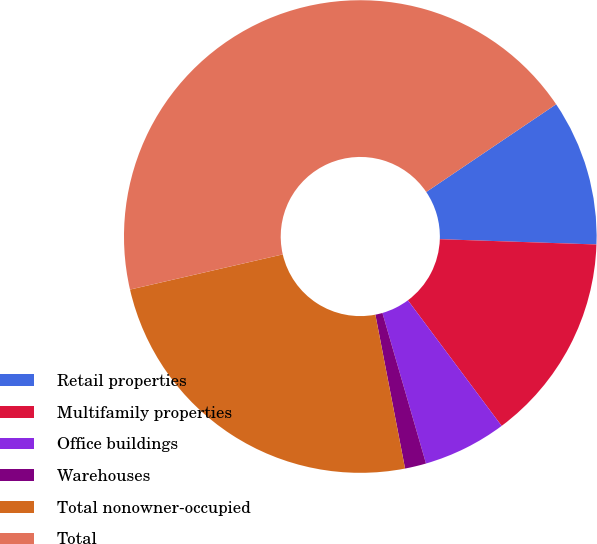Convert chart. <chart><loc_0><loc_0><loc_500><loc_500><pie_chart><fcel>Retail properties<fcel>Multifamily properties<fcel>Office buildings<fcel>Warehouses<fcel>Total nonowner-occupied<fcel>Total<nl><fcel>9.99%<fcel>14.26%<fcel>5.72%<fcel>1.45%<fcel>24.43%<fcel>44.15%<nl></chart> 